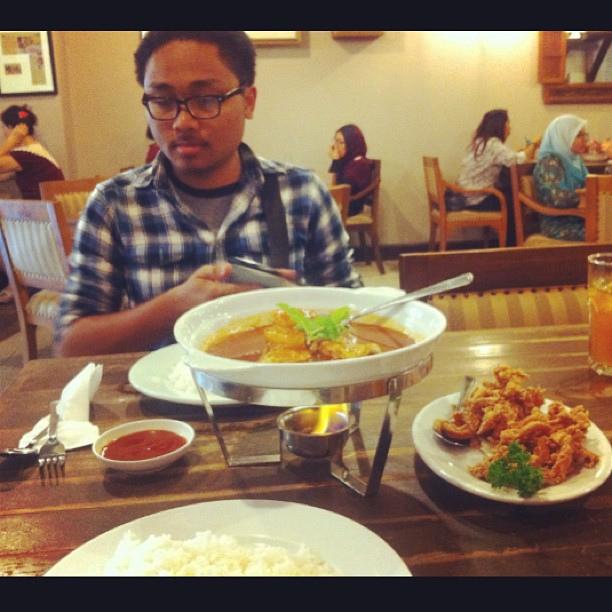What food is on the plate?
Keep it brief. Chicken. Where are the food?
Give a very brief answer. Table. What soup is this?
Give a very brief answer. Tomato. What kind of food is this?
Give a very brief answer. Asian. Is this a restaurant?
Give a very brief answer. Yes. 